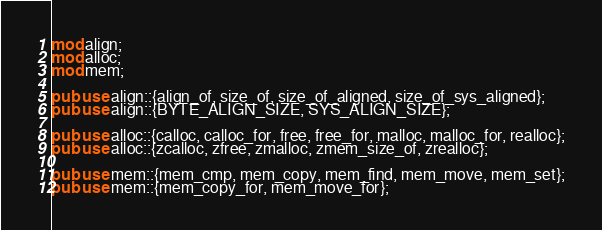<code> <loc_0><loc_0><loc_500><loc_500><_Rust_>mod align;
mod alloc;
mod mem;

pub use align::{align_of, size_of, size_of_aligned, size_of_sys_aligned};
pub use align::{BYTE_ALIGN_SIZE, SYS_ALIGN_SIZE};

pub use alloc::{calloc, calloc_for, free, free_for, malloc, malloc_for, realloc};
pub use alloc::{zcalloc, zfree, zmalloc, zmem_size_of, zrealloc};

pub use mem::{mem_cmp, mem_copy, mem_find, mem_move, mem_set};
pub use mem::{mem_copy_for, mem_move_for};
</code> 